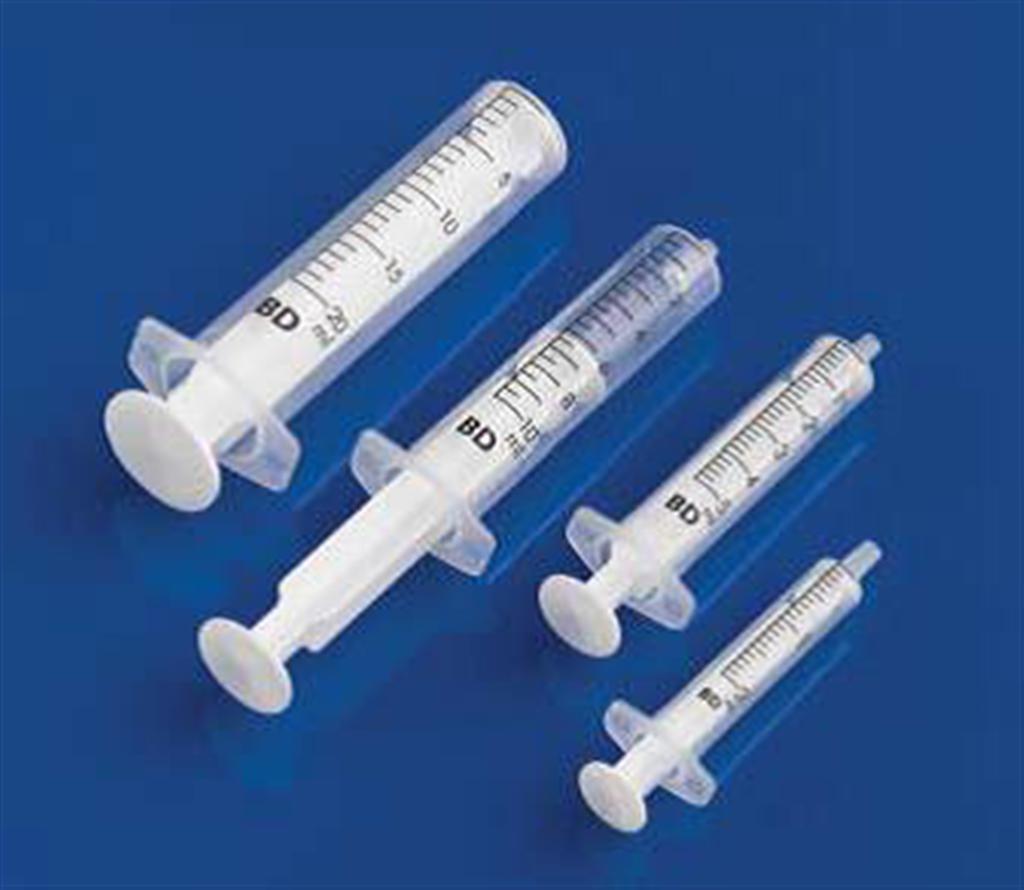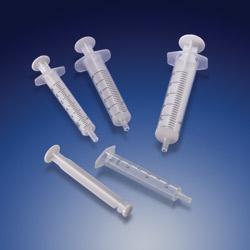The first image is the image on the left, the second image is the image on the right. Evaluate the accuracy of this statement regarding the images: "Left image shows exactly one syringe-type item, with a green plunger.". Is it true? Answer yes or no. No. The first image is the image on the left, the second image is the image on the right. Analyze the images presented: Is the assertion "There is a single green syringe in the left image" valid? Answer yes or no. No. 